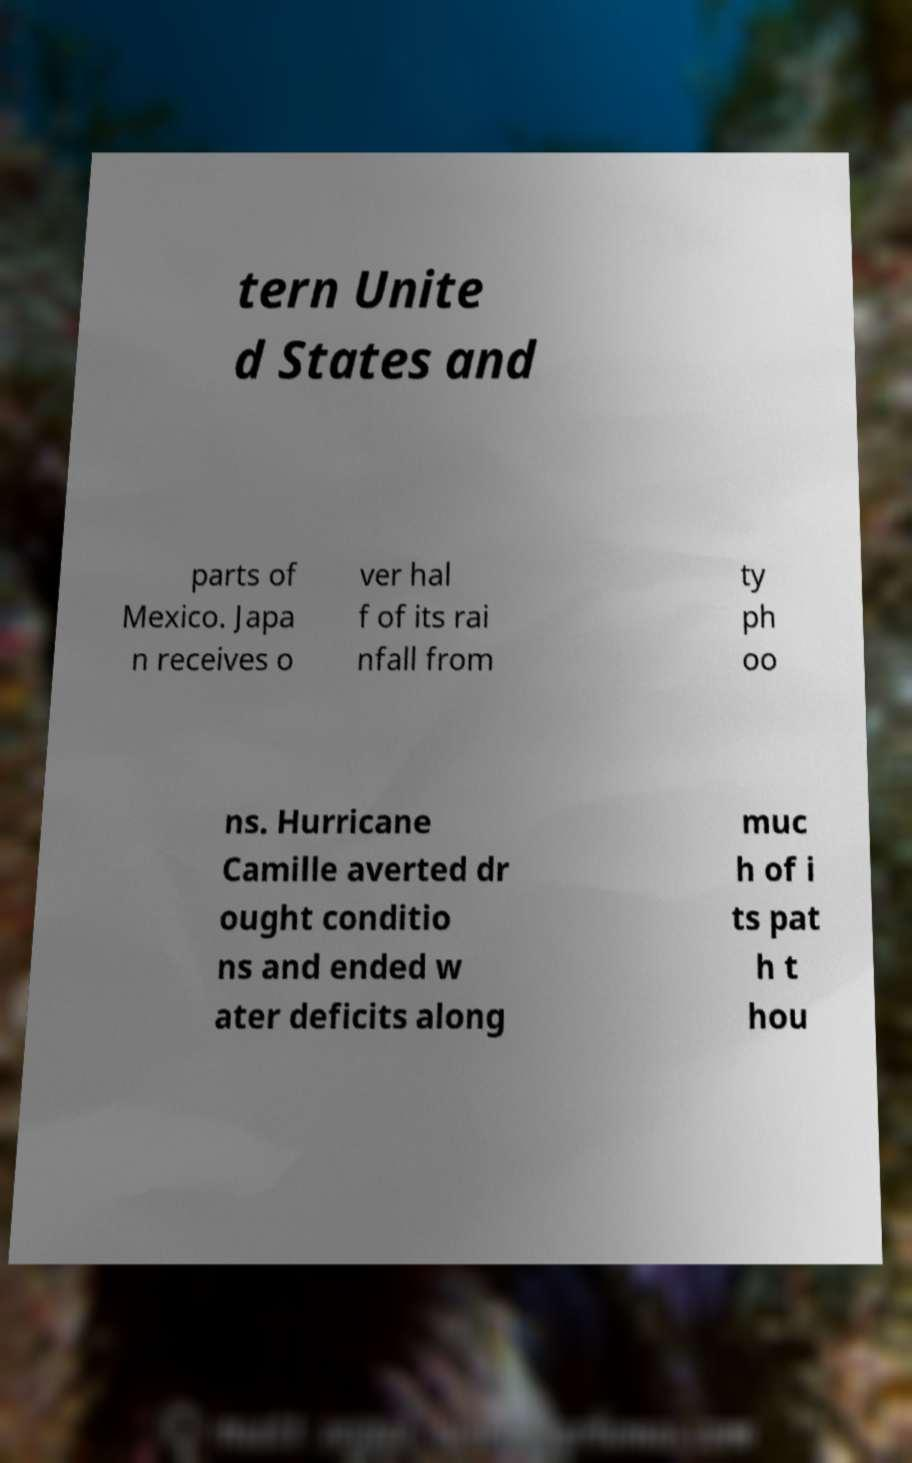Can you read and provide the text displayed in the image?This photo seems to have some interesting text. Can you extract and type it out for me? tern Unite d States and parts of Mexico. Japa n receives o ver hal f of its rai nfall from ty ph oo ns. Hurricane Camille averted dr ought conditio ns and ended w ater deficits along muc h of i ts pat h t hou 